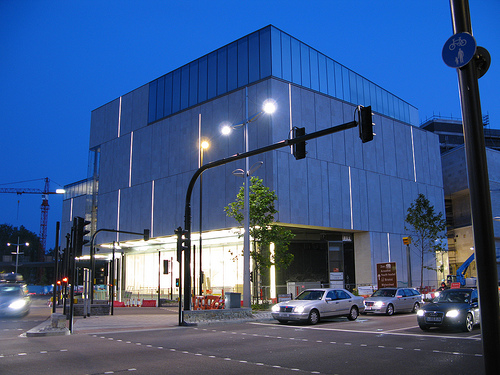How many cars can be seen? In the scene, we can observe a total of four cars parked along the street, with the building's unique architecture and the dusk sky providing an intriguing backdrop. 